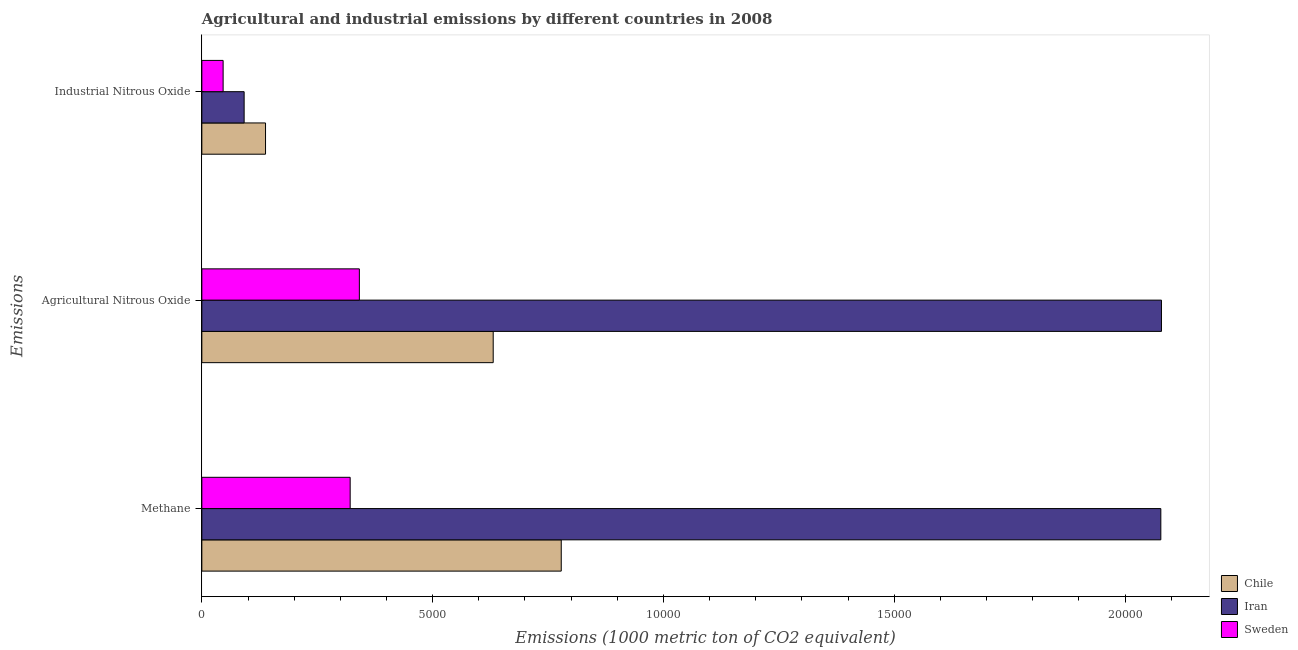How many different coloured bars are there?
Offer a very short reply. 3. Are the number of bars on each tick of the Y-axis equal?
Offer a very short reply. Yes. How many bars are there on the 3rd tick from the top?
Provide a succinct answer. 3. How many bars are there on the 1st tick from the bottom?
Your answer should be compact. 3. What is the label of the 2nd group of bars from the top?
Provide a short and direct response. Agricultural Nitrous Oxide. What is the amount of agricultural nitrous oxide emissions in Chile?
Your answer should be compact. 6312. Across all countries, what is the maximum amount of agricultural nitrous oxide emissions?
Your response must be concise. 2.08e+04. Across all countries, what is the minimum amount of agricultural nitrous oxide emissions?
Give a very brief answer. 3412.4. In which country was the amount of methane emissions maximum?
Keep it short and to the point. Iran. In which country was the amount of agricultural nitrous oxide emissions minimum?
Your response must be concise. Sweden. What is the total amount of agricultural nitrous oxide emissions in the graph?
Your answer should be very brief. 3.05e+04. What is the difference between the amount of industrial nitrous oxide emissions in Iran and that in Chile?
Ensure brevity in your answer.  -463.5. What is the difference between the amount of agricultural nitrous oxide emissions in Sweden and the amount of industrial nitrous oxide emissions in Iran?
Provide a short and direct response. 2496.2. What is the average amount of methane emissions per country?
Offer a very short reply. 1.06e+04. What is the difference between the amount of industrial nitrous oxide emissions and amount of methane emissions in Chile?
Keep it short and to the point. -6406.4. In how many countries, is the amount of agricultural nitrous oxide emissions greater than 14000 metric ton?
Make the answer very short. 1. What is the ratio of the amount of agricultural nitrous oxide emissions in Iran to that in Sweden?
Offer a very short reply. 6.09. What is the difference between the highest and the second highest amount of agricultural nitrous oxide emissions?
Give a very brief answer. 1.45e+04. What is the difference between the highest and the lowest amount of methane emissions?
Give a very brief answer. 1.76e+04. In how many countries, is the amount of agricultural nitrous oxide emissions greater than the average amount of agricultural nitrous oxide emissions taken over all countries?
Provide a short and direct response. 1. Is it the case that in every country, the sum of the amount of methane emissions and amount of agricultural nitrous oxide emissions is greater than the amount of industrial nitrous oxide emissions?
Offer a terse response. Yes. How many bars are there?
Ensure brevity in your answer.  9. Are all the bars in the graph horizontal?
Ensure brevity in your answer.  Yes. What is the difference between two consecutive major ticks on the X-axis?
Provide a succinct answer. 5000. Are the values on the major ticks of X-axis written in scientific E-notation?
Offer a very short reply. No. Does the graph contain grids?
Your answer should be compact. No. How many legend labels are there?
Offer a very short reply. 3. What is the title of the graph?
Your response must be concise. Agricultural and industrial emissions by different countries in 2008. What is the label or title of the X-axis?
Your response must be concise. Emissions (1000 metric ton of CO2 equivalent). What is the label or title of the Y-axis?
Your answer should be very brief. Emissions. What is the Emissions (1000 metric ton of CO2 equivalent) in Chile in Methane?
Provide a short and direct response. 7786.1. What is the Emissions (1000 metric ton of CO2 equivalent) in Iran in Methane?
Provide a short and direct response. 2.08e+04. What is the Emissions (1000 metric ton of CO2 equivalent) of Sweden in Methane?
Give a very brief answer. 3213.3. What is the Emissions (1000 metric ton of CO2 equivalent) of Chile in Agricultural Nitrous Oxide?
Provide a succinct answer. 6312. What is the Emissions (1000 metric ton of CO2 equivalent) of Iran in Agricultural Nitrous Oxide?
Your response must be concise. 2.08e+04. What is the Emissions (1000 metric ton of CO2 equivalent) in Sweden in Agricultural Nitrous Oxide?
Ensure brevity in your answer.  3412.4. What is the Emissions (1000 metric ton of CO2 equivalent) of Chile in Industrial Nitrous Oxide?
Offer a terse response. 1379.7. What is the Emissions (1000 metric ton of CO2 equivalent) of Iran in Industrial Nitrous Oxide?
Give a very brief answer. 916.2. What is the Emissions (1000 metric ton of CO2 equivalent) in Sweden in Industrial Nitrous Oxide?
Offer a very short reply. 461.1. Across all Emissions, what is the maximum Emissions (1000 metric ton of CO2 equivalent) in Chile?
Keep it short and to the point. 7786.1. Across all Emissions, what is the maximum Emissions (1000 metric ton of CO2 equivalent) of Iran?
Make the answer very short. 2.08e+04. Across all Emissions, what is the maximum Emissions (1000 metric ton of CO2 equivalent) of Sweden?
Make the answer very short. 3412.4. Across all Emissions, what is the minimum Emissions (1000 metric ton of CO2 equivalent) of Chile?
Keep it short and to the point. 1379.7. Across all Emissions, what is the minimum Emissions (1000 metric ton of CO2 equivalent) in Iran?
Provide a succinct answer. 916.2. Across all Emissions, what is the minimum Emissions (1000 metric ton of CO2 equivalent) of Sweden?
Offer a terse response. 461.1. What is the total Emissions (1000 metric ton of CO2 equivalent) of Chile in the graph?
Provide a succinct answer. 1.55e+04. What is the total Emissions (1000 metric ton of CO2 equivalent) in Iran in the graph?
Keep it short and to the point. 4.25e+04. What is the total Emissions (1000 metric ton of CO2 equivalent) in Sweden in the graph?
Make the answer very short. 7086.8. What is the difference between the Emissions (1000 metric ton of CO2 equivalent) in Chile in Methane and that in Agricultural Nitrous Oxide?
Your answer should be compact. 1474.1. What is the difference between the Emissions (1000 metric ton of CO2 equivalent) in Iran in Methane and that in Agricultural Nitrous Oxide?
Keep it short and to the point. -13.8. What is the difference between the Emissions (1000 metric ton of CO2 equivalent) in Sweden in Methane and that in Agricultural Nitrous Oxide?
Your response must be concise. -199.1. What is the difference between the Emissions (1000 metric ton of CO2 equivalent) of Chile in Methane and that in Industrial Nitrous Oxide?
Give a very brief answer. 6406.4. What is the difference between the Emissions (1000 metric ton of CO2 equivalent) of Iran in Methane and that in Industrial Nitrous Oxide?
Make the answer very short. 1.99e+04. What is the difference between the Emissions (1000 metric ton of CO2 equivalent) in Sweden in Methane and that in Industrial Nitrous Oxide?
Your response must be concise. 2752.2. What is the difference between the Emissions (1000 metric ton of CO2 equivalent) in Chile in Agricultural Nitrous Oxide and that in Industrial Nitrous Oxide?
Ensure brevity in your answer.  4932.3. What is the difference between the Emissions (1000 metric ton of CO2 equivalent) in Iran in Agricultural Nitrous Oxide and that in Industrial Nitrous Oxide?
Provide a short and direct response. 1.99e+04. What is the difference between the Emissions (1000 metric ton of CO2 equivalent) of Sweden in Agricultural Nitrous Oxide and that in Industrial Nitrous Oxide?
Your answer should be very brief. 2951.3. What is the difference between the Emissions (1000 metric ton of CO2 equivalent) of Chile in Methane and the Emissions (1000 metric ton of CO2 equivalent) of Iran in Agricultural Nitrous Oxide?
Your response must be concise. -1.30e+04. What is the difference between the Emissions (1000 metric ton of CO2 equivalent) in Chile in Methane and the Emissions (1000 metric ton of CO2 equivalent) in Sweden in Agricultural Nitrous Oxide?
Your answer should be compact. 4373.7. What is the difference between the Emissions (1000 metric ton of CO2 equivalent) of Iran in Methane and the Emissions (1000 metric ton of CO2 equivalent) of Sweden in Agricultural Nitrous Oxide?
Offer a terse response. 1.74e+04. What is the difference between the Emissions (1000 metric ton of CO2 equivalent) of Chile in Methane and the Emissions (1000 metric ton of CO2 equivalent) of Iran in Industrial Nitrous Oxide?
Provide a succinct answer. 6869.9. What is the difference between the Emissions (1000 metric ton of CO2 equivalent) in Chile in Methane and the Emissions (1000 metric ton of CO2 equivalent) in Sweden in Industrial Nitrous Oxide?
Give a very brief answer. 7325. What is the difference between the Emissions (1000 metric ton of CO2 equivalent) of Iran in Methane and the Emissions (1000 metric ton of CO2 equivalent) of Sweden in Industrial Nitrous Oxide?
Your answer should be compact. 2.03e+04. What is the difference between the Emissions (1000 metric ton of CO2 equivalent) of Chile in Agricultural Nitrous Oxide and the Emissions (1000 metric ton of CO2 equivalent) of Iran in Industrial Nitrous Oxide?
Your answer should be compact. 5395.8. What is the difference between the Emissions (1000 metric ton of CO2 equivalent) of Chile in Agricultural Nitrous Oxide and the Emissions (1000 metric ton of CO2 equivalent) of Sweden in Industrial Nitrous Oxide?
Provide a succinct answer. 5850.9. What is the difference between the Emissions (1000 metric ton of CO2 equivalent) in Iran in Agricultural Nitrous Oxide and the Emissions (1000 metric ton of CO2 equivalent) in Sweden in Industrial Nitrous Oxide?
Make the answer very short. 2.03e+04. What is the average Emissions (1000 metric ton of CO2 equivalent) of Chile per Emissions?
Offer a very short reply. 5159.27. What is the average Emissions (1000 metric ton of CO2 equivalent) of Iran per Emissions?
Keep it short and to the point. 1.42e+04. What is the average Emissions (1000 metric ton of CO2 equivalent) in Sweden per Emissions?
Keep it short and to the point. 2362.27. What is the difference between the Emissions (1000 metric ton of CO2 equivalent) in Chile and Emissions (1000 metric ton of CO2 equivalent) in Iran in Methane?
Offer a very short reply. -1.30e+04. What is the difference between the Emissions (1000 metric ton of CO2 equivalent) in Chile and Emissions (1000 metric ton of CO2 equivalent) in Sweden in Methane?
Your answer should be compact. 4572.8. What is the difference between the Emissions (1000 metric ton of CO2 equivalent) in Iran and Emissions (1000 metric ton of CO2 equivalent) in Sweden in Methane?
Provide a succinct answer. 1.76e+04. What is the difference between the Emissions (1000 metric ton of CO2 equivalent) of Chile and Emissions (1000 metric ton of CO2 equivalent) of Iran in Agricultural Nitrous Oxide?
Keep it short and to the point. -1.45e+04. What is the difference between the Emissions (1000 metric ton of CO2 equivalent) of Chile and Emissions (1000 metric ton of CO2 equivalent) of Sweden in Agricultural Nitrous Oxide?
Your answer should be compact. 2899.6. What is the difference between the Emissions (1000 metric ton of CO2 equivalent) in Iran and Emissions (1000 metric ton of CO2 equivalent) in Sweden in Agricultural Nitrous Oxide?
Make the answer very short. 1.74e+04. What is the difference between the Emissions (1000 metric ton of CO2 equivalent) of Chile and Emissions (1000 metric ton of CO2 equivalent) of Iran in Industrial Nitrous Oxide?
Keep it short and to the point. 463.5. What is the difference between the Emissions (1000 metric ton of CO2 equivalent) of Chile and Emissions (1000 metric ton of CO2 equivalent) of Sweden in Industrial Nitrous Oxide?
Keep it short and to the point. 918.6. What is the difference between the Emissions (1000 metric ton of CO2 equivalent) in Iran and Emissions (1000 metric ton of CO2 equivalent) in Sweden in Industrial Nitrous Oxide?
Provide a succinct answer. 455.1. What is the ratio of the Emissions (1000 metric ton of CO2 equivalent) of Chile in Methane to that in Agricultural Nitrous Oxide?
Your answer should be very brief. 1.23. What is the ratio of the Emissions (1000 metric ton of CO2 equivalent) in Sweden in Methane to that in Agricultural Nitrous Oxide?
Provide a succinct answer. 0.94. What is the ratio of the Emissions (1000 metric ton of CO2 equivalent) in Chile in Methane to that in Industrial Nitrous Oxide?
Your answer should be compact. 5.64. What is the ratio of the Emissions (1000 metric ton of CO2 equivalent) of Iran in Methane to that in Industrial Nitrous Oxide?
Offer a very short reply. 22.68. What is the ratio of the Emissions (1000 metric ton of CO2 equivalent) in Sweden in Methane to that in Industrial Nitrous Oxide?
Keep it short and to the point. 6.97. What is the ratio of the Emissions (1000 metric ton of CO2 equivalent) of Chile in Agricultural Nitrous Oxide to that in Industrial Nitrous Oxide?
Provide a succinct answer. 4.57. What is the ratio of the Emissions (1000 metric ton of CO2 equivalent) of Iran in Agricultural Nitrous Oxide to that in Industrial Nitrous Oxide?
Your answer should be compact. 22.69. What is the ratio of the Emissions (1000 metric ton of CO2 equivalent) of Sweden in Agricultural Nitrous Oxide to that in Industrial Nitrous Oxide?
Your answer should be very brief. 7.4. What is the difference between the highest and the second highest Emissions (1000 metric ton of CO2 equivalent) in Chile?
Give a very brief answer. 1474.1. What is the difference between the highest and the second highest Emissions (1000 metric ton of CO2 equivalent) in Iran?
Ensure brevity in your answer.  13.8. What is the difference between the highest and the second highest Emissions (1000 metric ton of CO2 equivalent) of Sweden?
Give a very brief answer. 199.1. What is the difference between the highest and the lowest Emissions (1000 metric ton of CO2 equivalent) of Chile?
Offer a terse response. 6406.4. What is the difference between the highest and the lowest Emissions (1000 metric ton of CO2 equivalent) in Iran?
Your response must be concise. 1.99e+04. What is the difference between the highest and the lowest Emissions (1000 metric ton of CO2 equivalent) of Sweden?
Ensure brevity in your answer.  2951.3. 